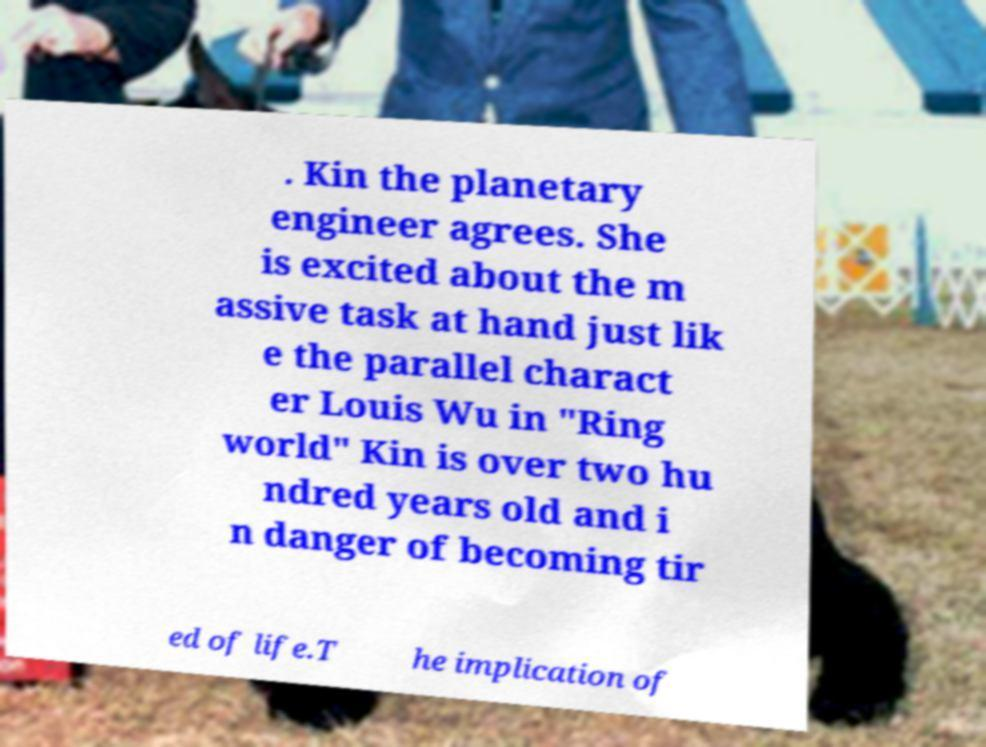Could you assist in decoding the text presented in this image and type it out clearly? . Kin the planetary engineer agrees. She is excited about the m assive task at hand just lik e the parallel charact er Louis Wu in "Ring world" Kin is over two hu ndred years old and i n danger of becoming tir ed of life.T he implication of 